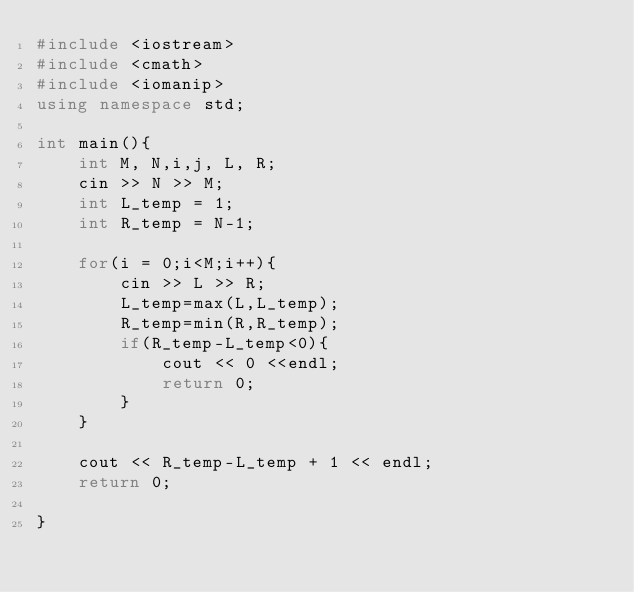Convert code to text. <code><loc_0><loc_0><loc_500><loc_500><_C++_>#include <iostream>
#include <cmath>
#include <iomanip>
using namespace std;

int main(){
    int M, N,i,j, L, R;
    cin >> N >> M;
    int L_temp = 1;
    int R_temp = N-1;

    for(i = 0;i<M;i++){        
        cin >> L >> R;
        L_temp=max(L,L_temp);
        R_temp=min(R,R_temp);
        if(R_temp-L_temp<0){
            cout << 0 <<endl;
            return 0;
        }
    }

    cout << R_temp-L_temp + 1 << endl;
    return 0;

}</code> 